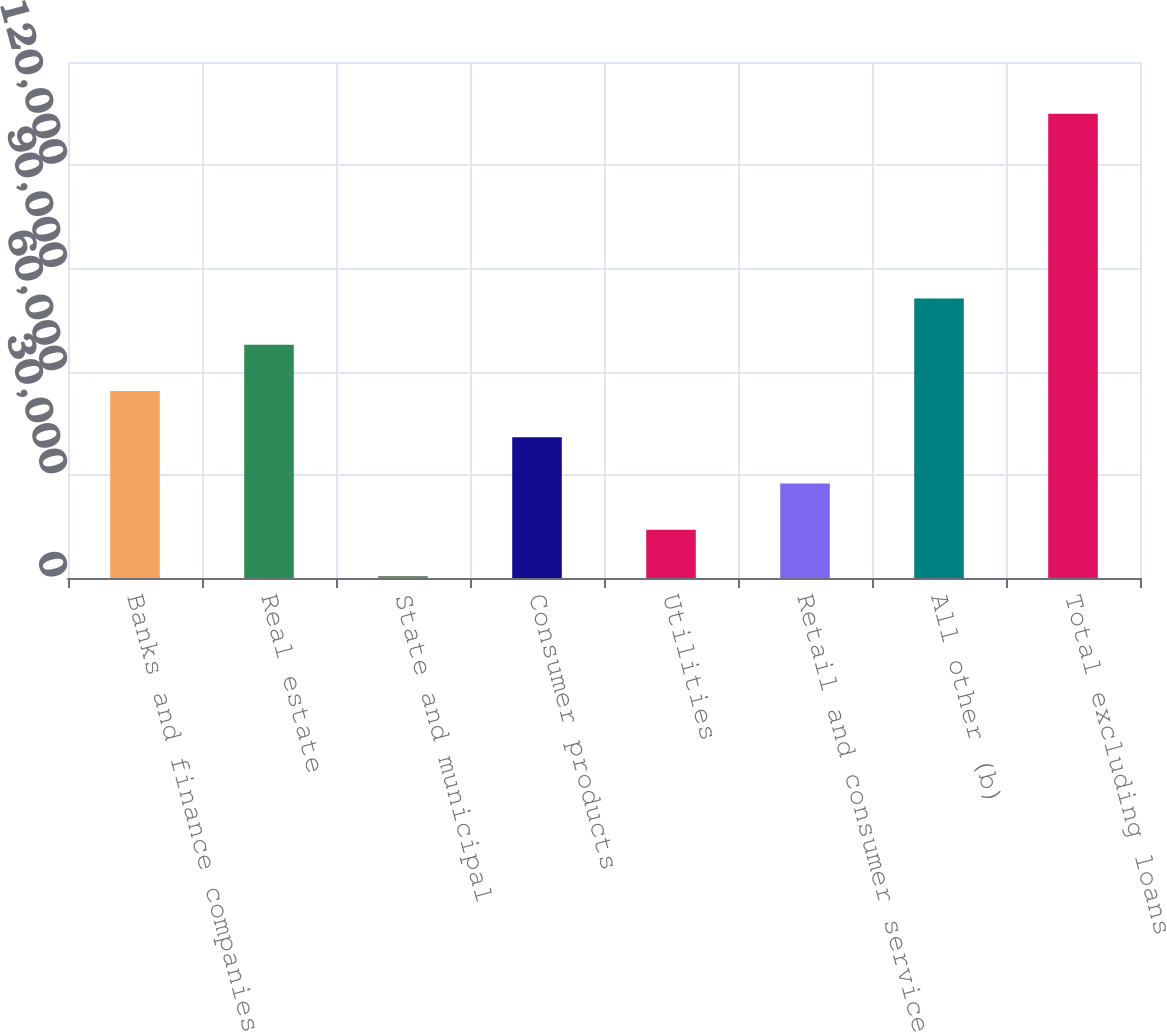<chart> <loc_0><loc_0><loc_500><loc_500><bar_chart><fcel>Banks and finance companies<fcel>Real estate<fcel>State and municipal<fcel>Consumer products<fcel>Utilities<fcel>Retail and consumer services<fcel>All other (b)<fcel>Total excluding loans<nl><fcel>54347.8<fcel>67787<fcel>591<fcel>40908.6<fcel>14030.2<fcel>27469.4<fcel>81226.2<fcel>134983<nl></chart> 